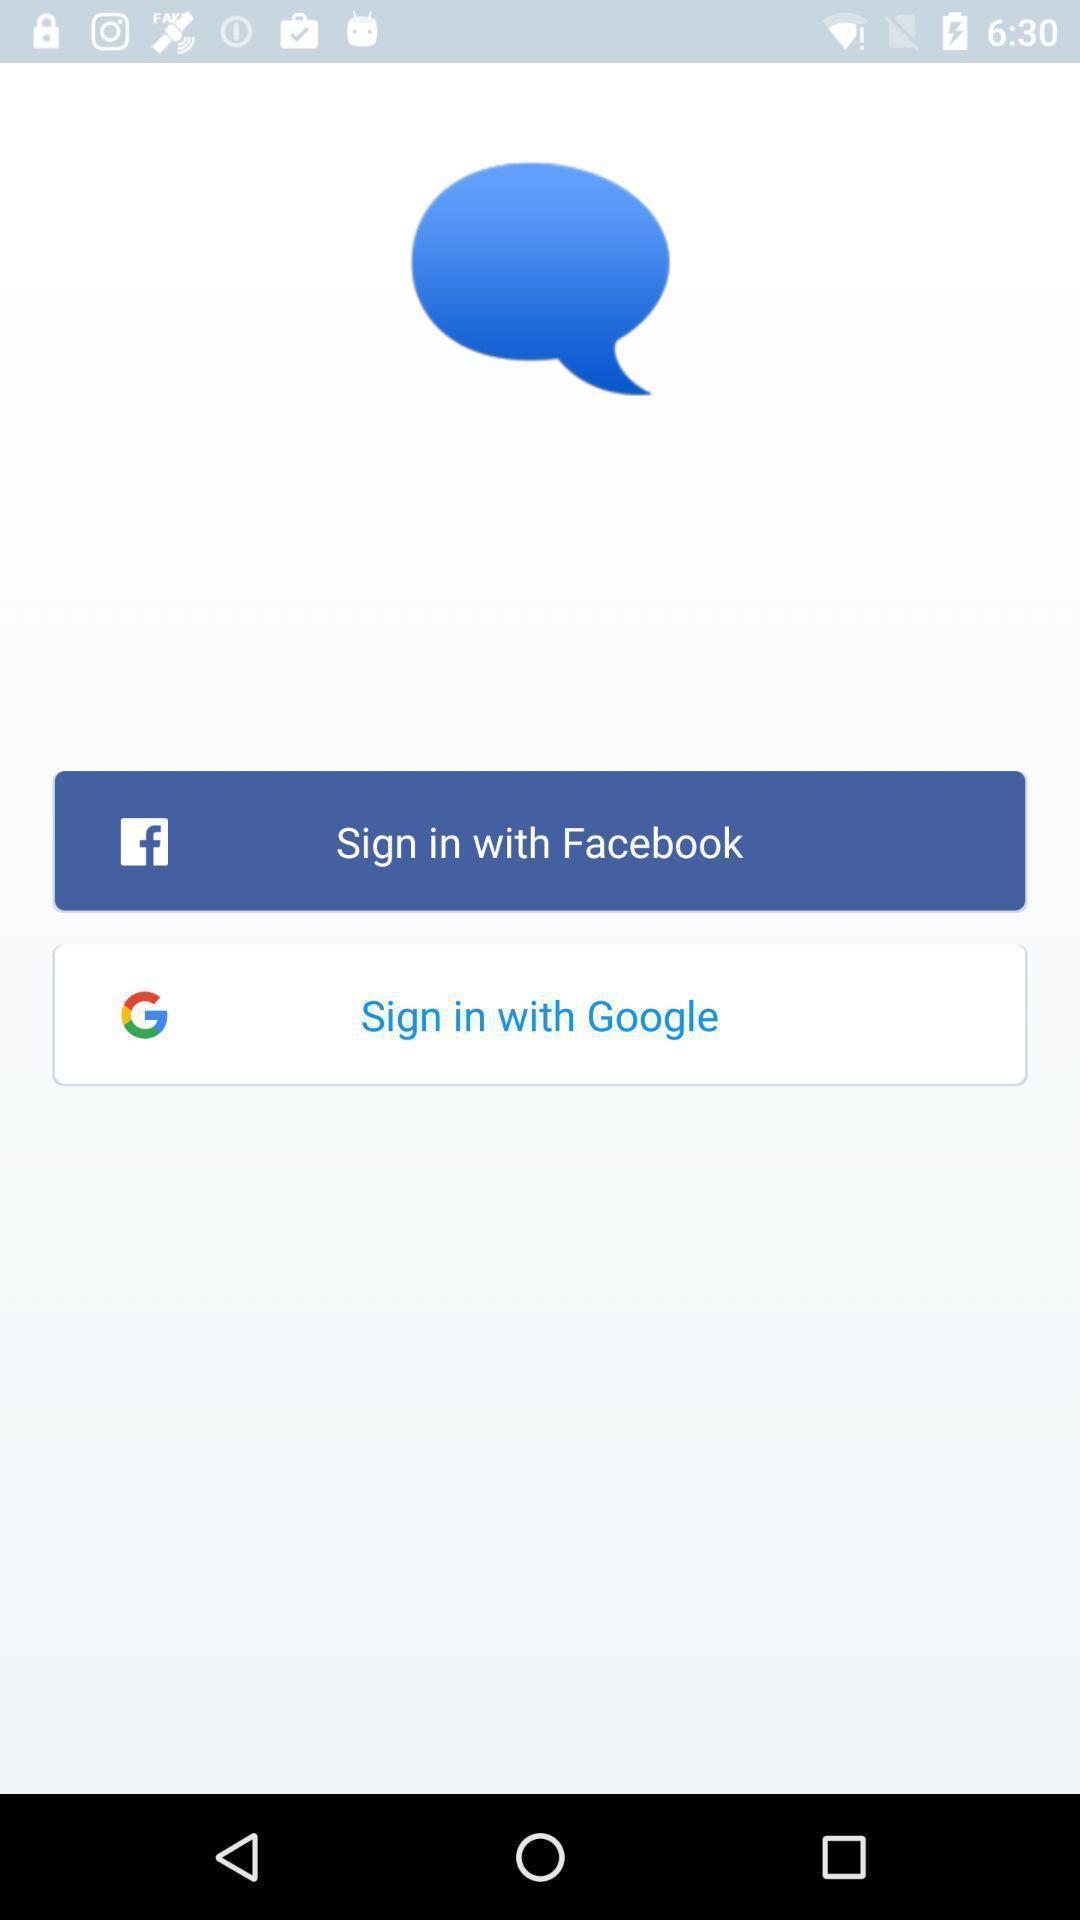Provide a detailed account of this screenshot. Sign in page of a social media app. 